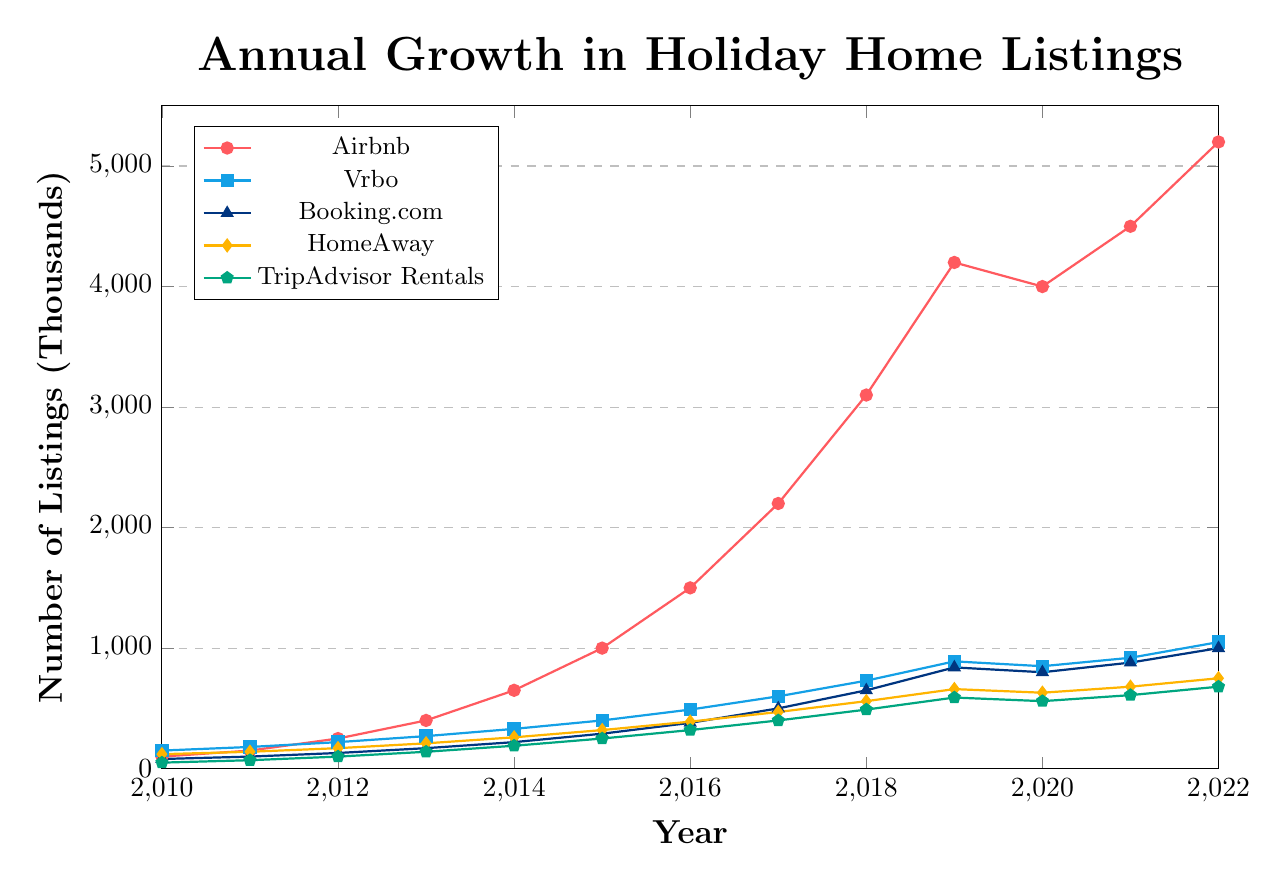Which platform showed the highest growth from 2010 to 2022? To determine the highest growth, calculate the difference in the number of listings from 2010 to 2022 for each platform. Airbnb’s listings grew from 100 to 5200, a difference of 5100; Vrbo’s from 150 to 1050, a difference of 900; Booking.com’s from 80 to 1000, a difference of 920; HomeAway’s from 120 to 750, a difference of 630; TripAdvisor Rentals’ from 50 to 680, a difference of 630. The highest growth is 5100 (Airbnb)
Answer: Airbnb In which year did Booking.com surpass 500 listings? Examine the data series for Booking.com and find the first year when the listings are above 500. From the chart, Booking.com surpassed 500 listings in 2017.
Answer: 2017 What was the annual growth rate of Vrbo listings from 2016 to 2017? Use the formula for annual growth rate: ((Value_end - Value_start) / Value_start) * 100%. For Vrbo, the listings in 2016 were 490 and in 2017 were 600. So, ((600 - 490) / 490) * 100% = 22.45%.
Answer: 22.45% How many total listings did Airbnb and HomeAway have in 2015? Sum the number of listings for Airbnb and HomeAway in 2015. Airbnb had 1000 listings and HomeAway had 320 listings. Therefore, 1000 + 320 = 1320.
Answer: 1320 Between 2019 and 2020, did any platform experience a decline in listings? If so, which one(s)? Compare the listings for each platform in 2019 and 2020. Airbnb declined from 4200 to 4000, Vrbo from 890 to 850, Booking.com from 840 to 800, HomeAway from 660 to 630, and TripAdvisor Rentals from 590 to 560. All platforms experienced a decline.
Answer: All platforms Which platform had the smallest number of listings in 2010, and how many? Look at the number of listings for each platform in 2010. TripAdvisor Rentals had the smallest number with 50 listings.
Answer: TripAdvisor Rentals, 50 By how much did the number of listings for TripAdvisor Rentals increase from 2010 to 2012? Subtract the number of listings in 2010 from the number in 2012 for TripAdvisor Rentals. The listings increased from 50 to 100, so 100 - 50 = 50.
Answer: 50 What is the average number of listings for HomeAway from 2010 to 2022? Calculate the average by summing the listings from 2010 to 2022 and then dividing by the number of years (13 years). Total listings = 120+140+170+210+260+320+390+470+560+660+630+680+750 = 6260. So, 6260 / 13 ≈ 481.54.
Answer: 481.54 Which platform had a higher number of listings in 2021, Vrbo or TripAdvisor Rentals? Compare the listings in 2021 for Vrbo and TripAdvisor Rentals. Vrbo had 920 listings, and TripAdvisor Rentals had 610 listings. Vrbo had more.
Answer: Vrbo Calculate the rise in listings for Airbnb from 2014 to 2015. Subtract the number of listings in 2014 from 2015 for Airbnb. The listings increased from 650 to 1000, so 1000 - 650 = 350.
Answer: 350 